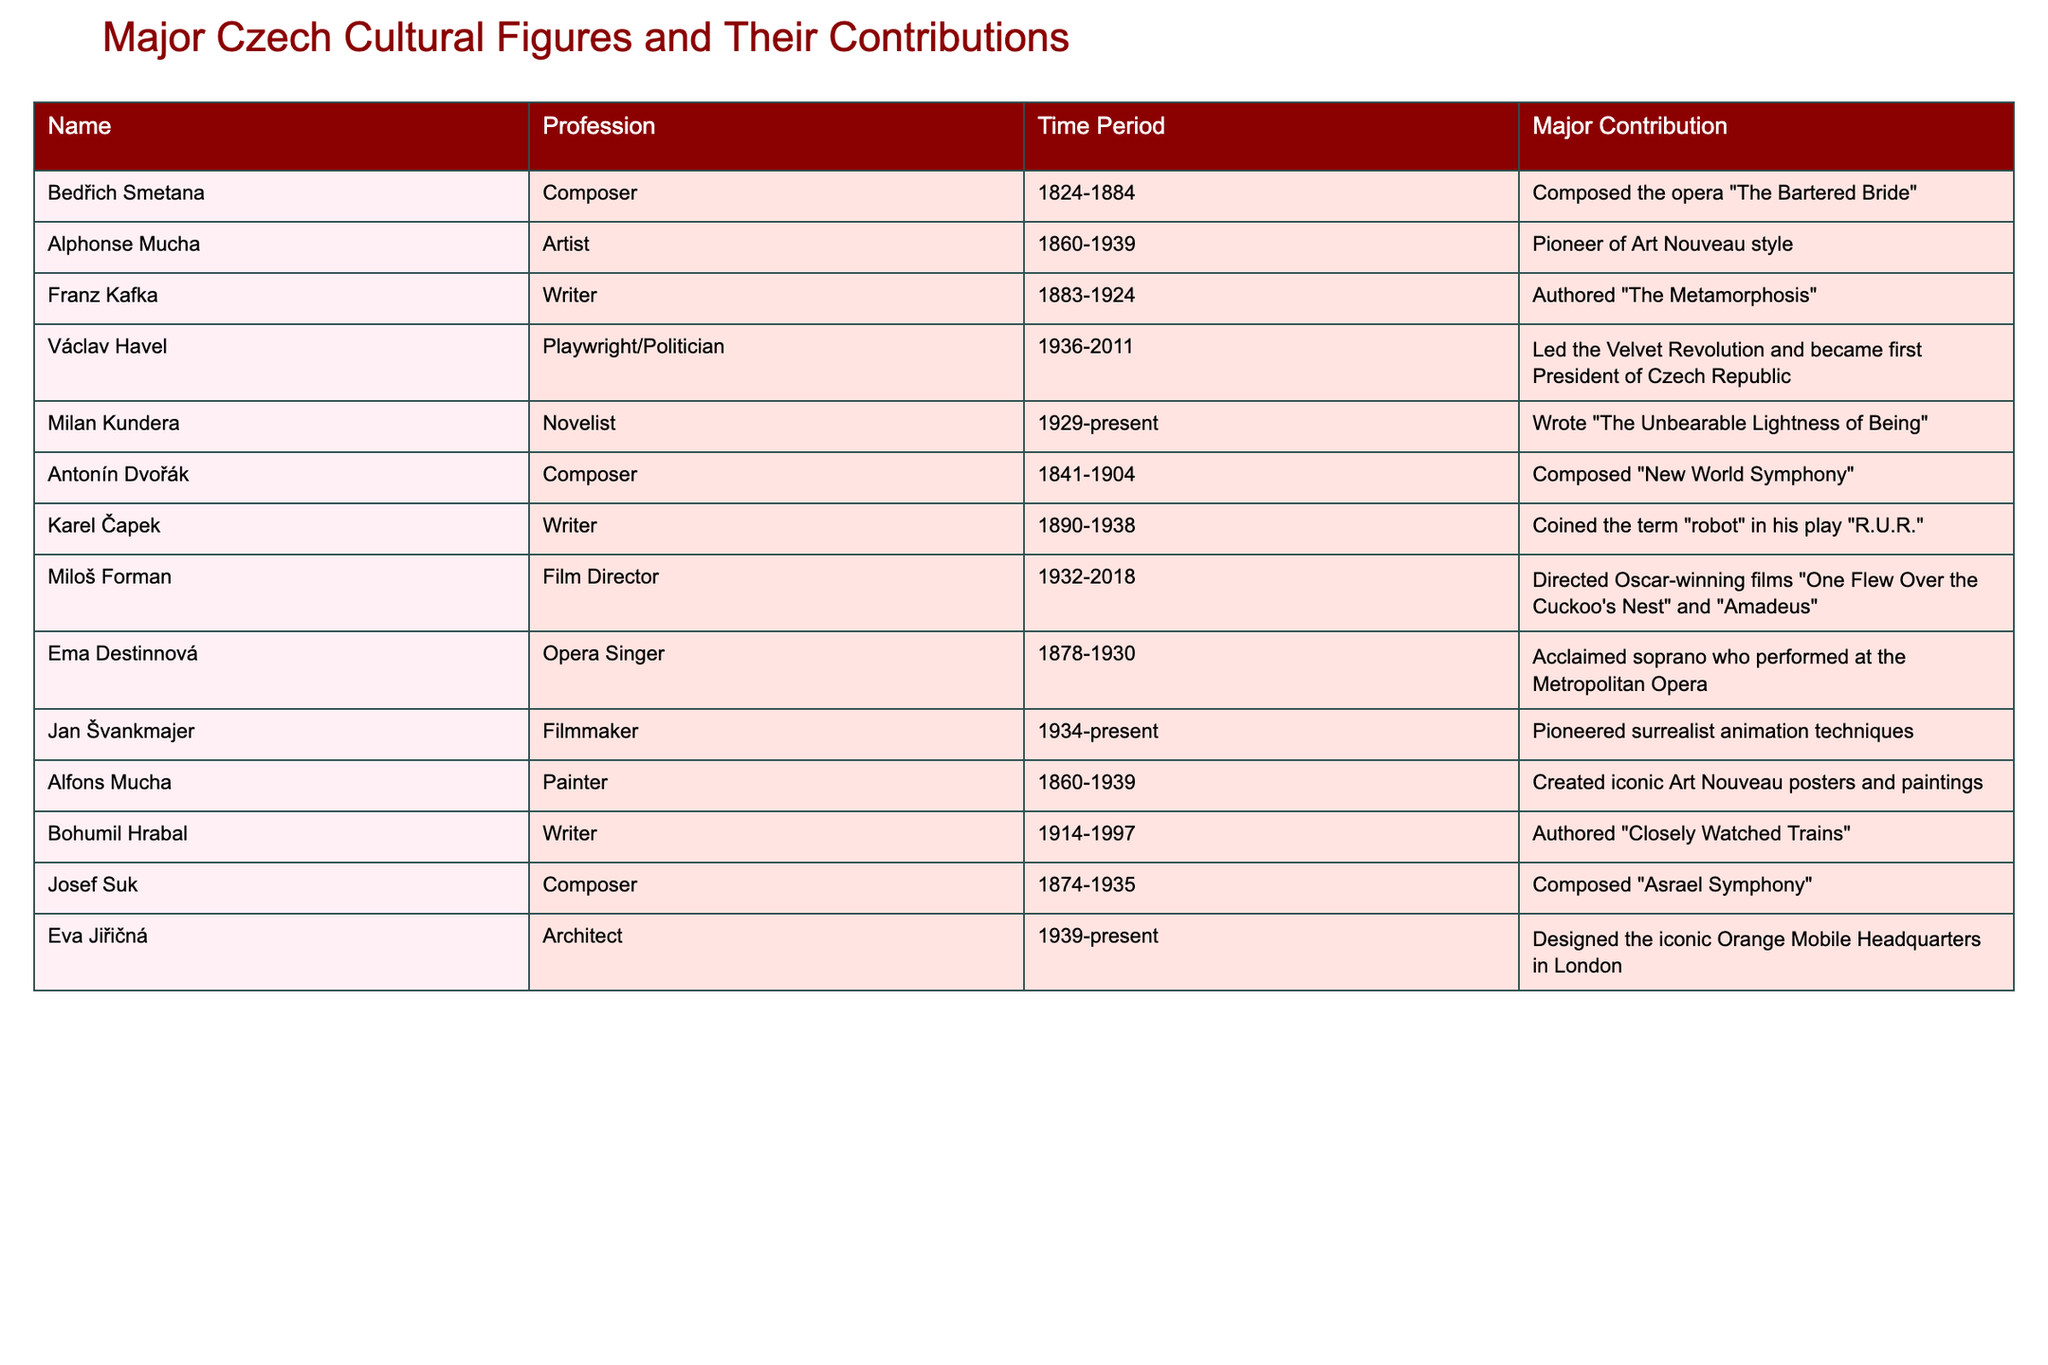What major contribution did Bedřich Smetana make? Bedřich Smetana is known for composing the opera "The Bartered Bride," which is listed in the table under his major contributions.
Answer: Composed the opera "The Bartered Bride" Which cultural figure is a pioneer of the Art Nouveau style? The table indicates that Alphonse Mucha is recognized as a pioneer of the Art Nouveau style, as stated in the contribution column.
Answer: Alphonse Mucha Did Franz Kafka author "The Metamorphosis"? The table clearly lists Franz Kafka as the writer of "The Metamorphosis," confirming the fact.
Answer: Yes Who is the first President of the Czech Republic? According to the table, Václav Havel led the Velvet Revolution and became the first President of the Czech Republic, which provides the necessary information.
Answer: Václav Havel How many composers are mentioned in the table? The table lists 4 composers: Bedřich Smetana, Antonín Dvořák, Josef Suk, and one additional composer when counting; thus, there are 4 composers in total.
Answer: 4 What is the profession of Ema Destinnová? The table specifies that Ema Destinnová was an opera singer, so this is the correct profession reflected in the data.
Answer: Opera Singer Which two works did Miloš Forman direct that won Oscars? From the table, Miloš Forman is noted for directing "One Flew Over the Cuckoo's Nest" and "Amadeus," which are both Oscar-winning films, allowing us to identify these contributions.
Answer: "One Flew Over the Cuckoo's Nest" and "Amadeus" Which cultural figure is associated with surrealist animation techniques? The table indicates that Jan Švankmajer is the filmmaker who pioneered surrealist animation techniques, providing the relevant information.
Answer: Jan Švankmajer What year range does Milan Kundera's contribution span? The table states that Milan Kundera's time period is from 1929 to the present, which defines the extent of his contributions outlined in the data.
Answer: 1929-present Who coined the term "robot"? The table reveals that Karel Čapek coined the term "robot" in his play "R.U.R.," answering the question about the origin of the term.
Answer: Karel Čapek 